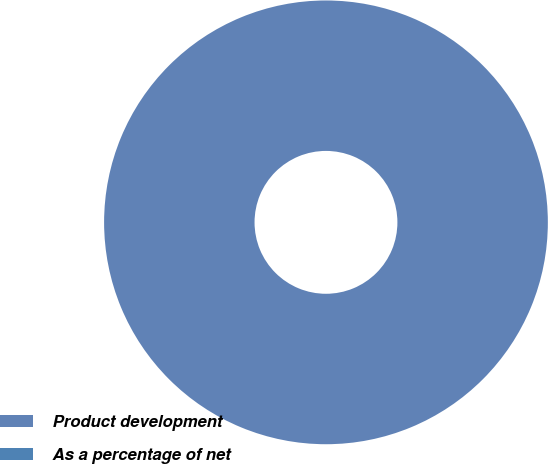<chart> <loc_0><loc_0><loc_500><loc_500><pie_chart><fcel>Product development<fcel>As a percentage of net<nl><fcel>100.0%<fcel>0.0%<nl></chart> 